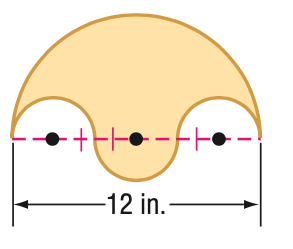Answer the mathemtical geometry problem and directly provide the correct option letter.
Question: Find the area of the shaded region.
Choices: A: 12.6 B: 50.3 C: 100.5 D: 402.1 B 